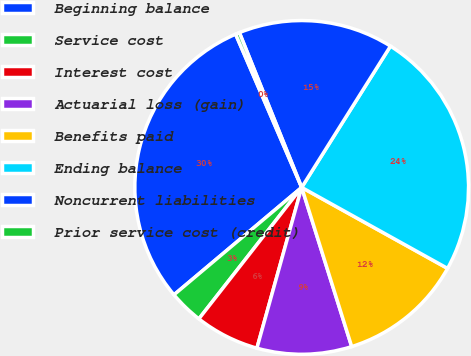<chart> <loc_0><loc_0><loc_500><loc_500><pie_chart><fcel>Beginning balance<fcel>Service cost<fcel>Interest cost<fcel>Actuarial loss (gain)<fcel>Benefits paid<fcel>Ending balance<fcel>Noncurrent liabilities<fcel>Prior service cost (credit)<nl><fcel>29.65%<fcel>3.31%<fcel>6.24%<fcel>9.17%<fcel>12.09%<fcel>24.14%<fcel>15.02%<fcel>0.39%<nl></chart> 